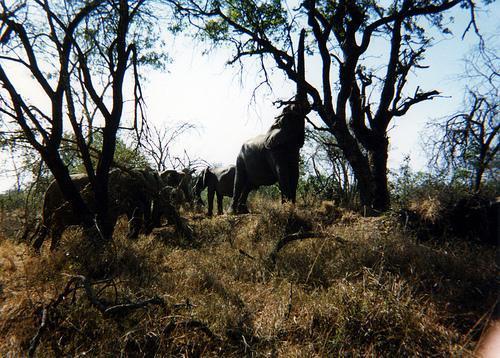How many elephants are there?
Give a very brief answer. 4. 